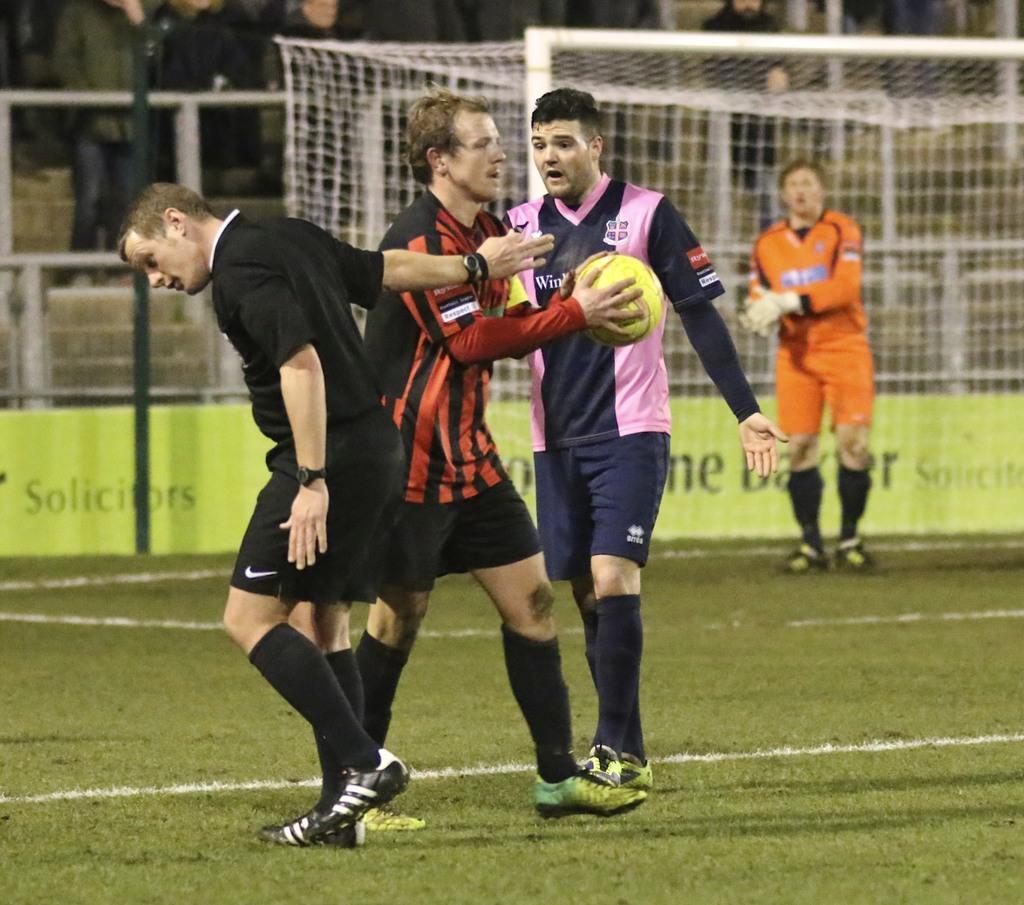In one or two sentences, can you explain what this image depicts? I think this image is taken from the football ground. There are three people standing. One person is holding football. at background I can see another person near the goal court. There are few people standing and watching the game. This is a green color banner which is put across the ground. 